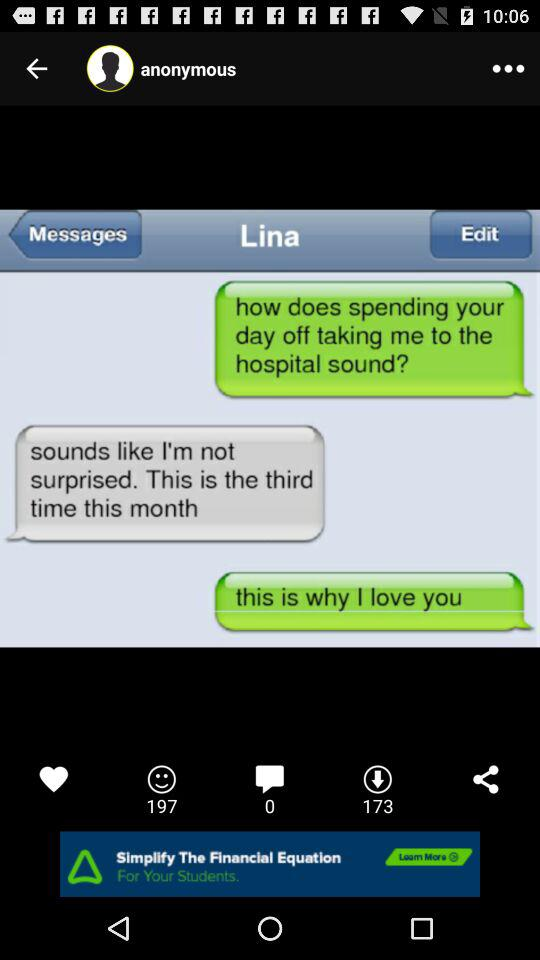What is the number of downloads?
When the provided information is insufficient, respond with <no answer>. <no answer> 